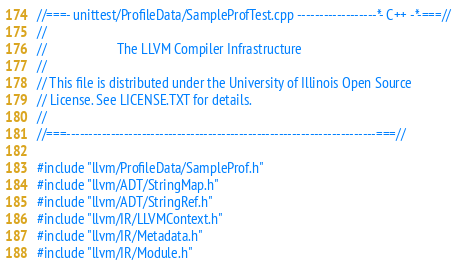<code> <loc_0><loc_0><loc_500><loc_500><_C++_>//===- unittest/ProfileData/SampleProfTest.cpp ------------------*- C++ -*-===//
//
//                     The LLVM Compiler Infrastructure
//
// This file is distributed under the University of Illinois Open Source
// License. See LICENSE.TXT for details.
//
//===----------------------------------------------------------------------===//

#include "llvm/ProfileData/SampleProf.h"
#include "llvm/ADT/StringMap.h"
#include "llvm/ADT/StringRef.h"
#include "llvm/IR/LLVMContext.h"
#include "llvm/IR/Metadata.h"
#include "llvm/IR/Module.h"</code> 